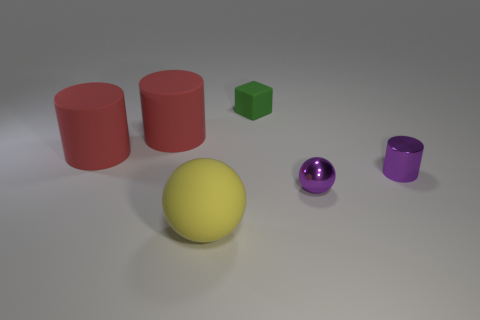Subtract all purple blocks. Subtract all green spheres. How many blocks are left? 1 Add 4 matte cubes. How many objects exist? 10 Subtract all cubes. How many objects are left? 5 Subtract all brown matte cubes. Subtract all metallic things. How many objects are left? 4 Add 4 small green cubes. How many small green cubes are left? 5 Add 6 large yellow matte balls. How many large yellow matte balls exist? 7 Subtract 0 cyan spheres. How many objects are left? 6 